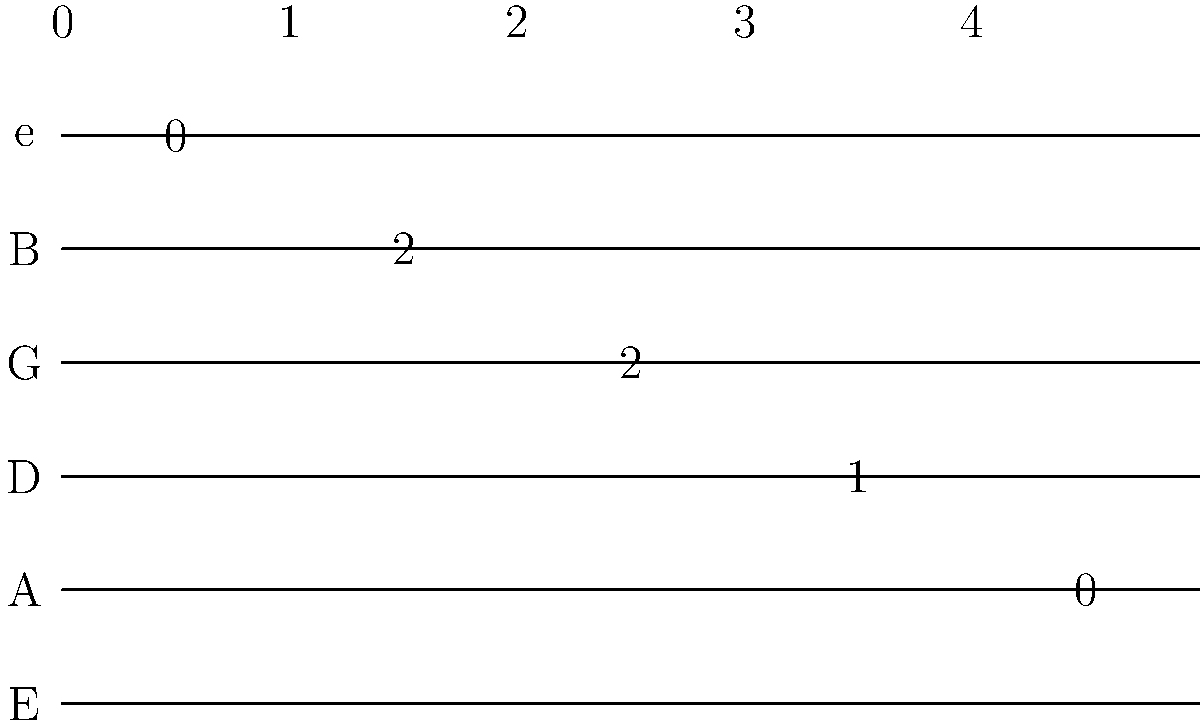In this guitar tablature for the intro of "You Oughta Know," what is the sequence of frets played on the G string? To answer this question, we need to follow these steps:

1. Identify the G string on the tablature: The G string is the third string from the top.

2. Read the numbers on the G string from left to right:
   - The first number we see is 2
   - There are no other numbers on this string

3. Interpret the tablature:
   - A number on a string indicates which fret should be played on that string
   - The absence of a number means the string is not played in that position

4. Determine the sequence:
   - We only see one number (2) on the G string
   - This means only the 2nd fret is played on the G string in this section

Therefore, the sequence of frets played on the G string is simply 2.
Answer: 2 